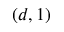Convert formula to latex. <formula><loc_0><loc_0><loc_500><loc_500>( d , 1 )</formula> 